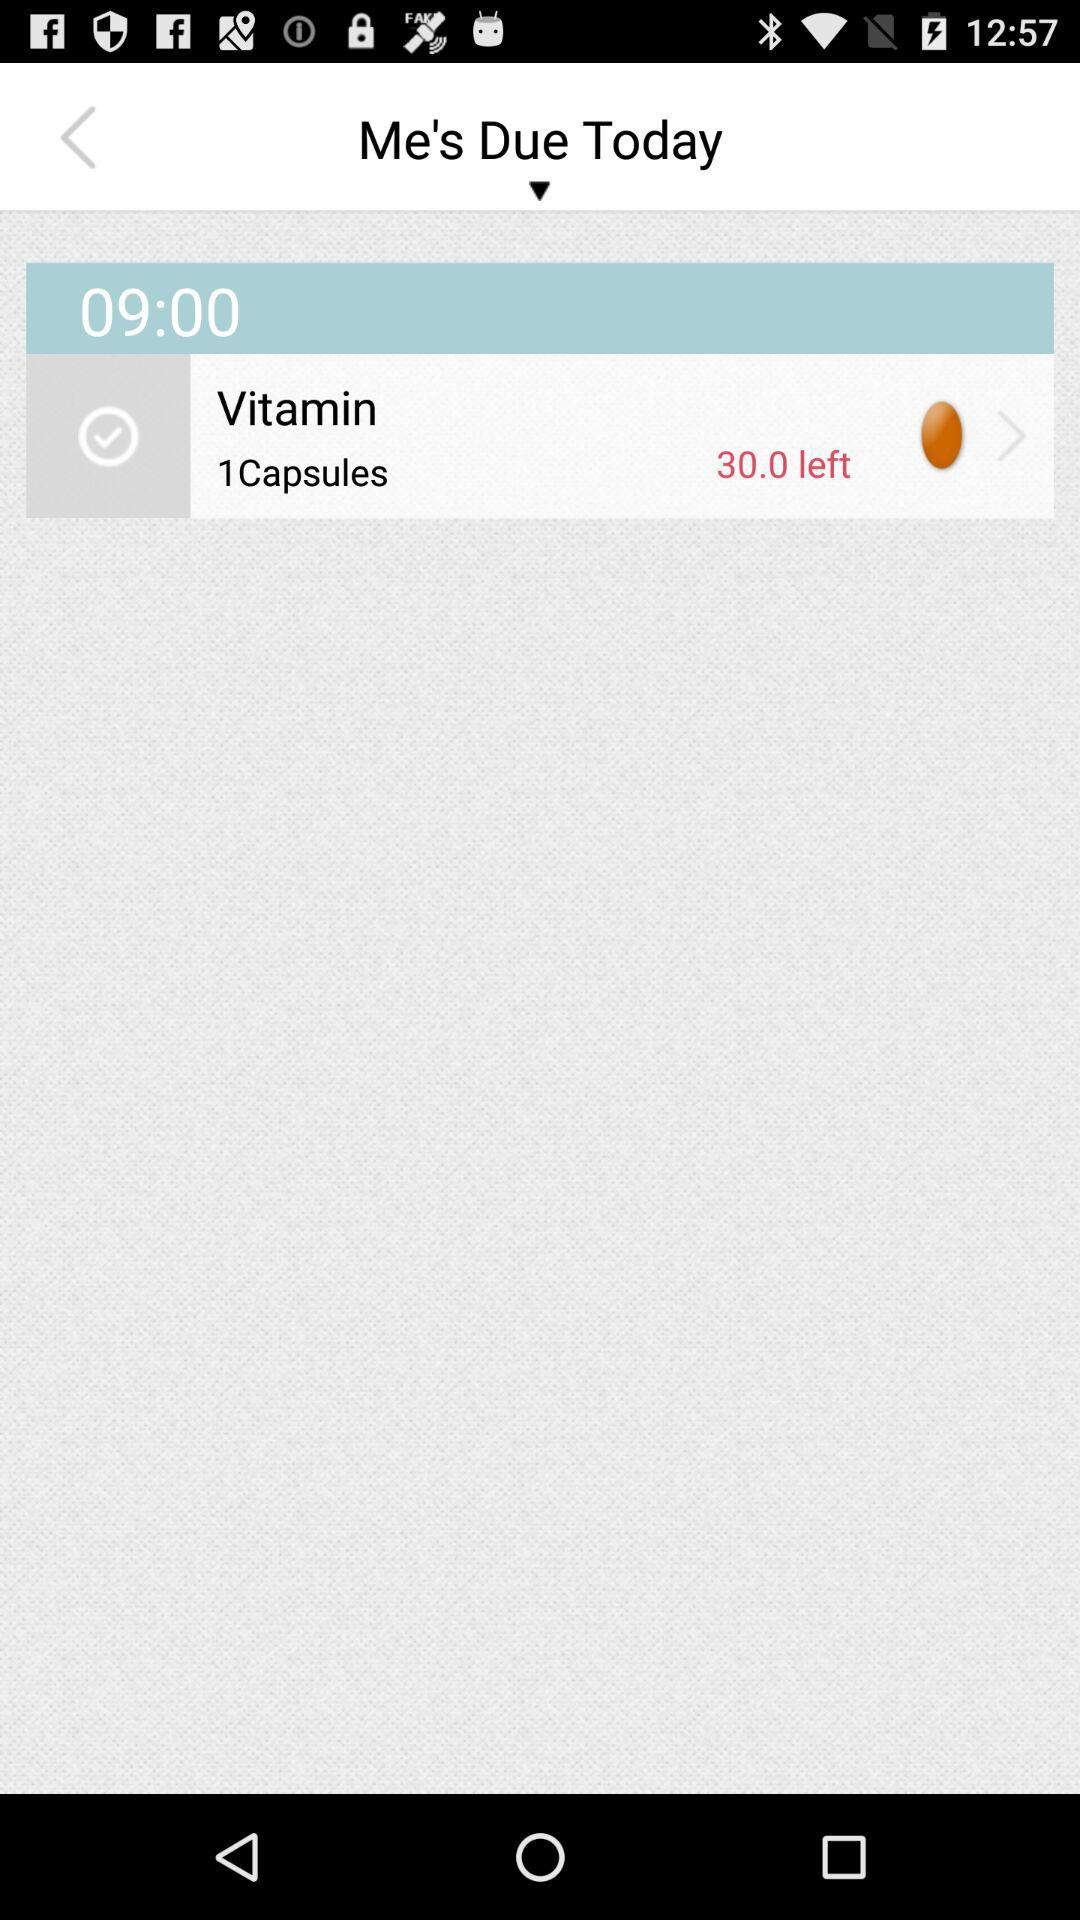How many more minutes are there until the next reminder?
Answer the question using a single word or phrase. 30 